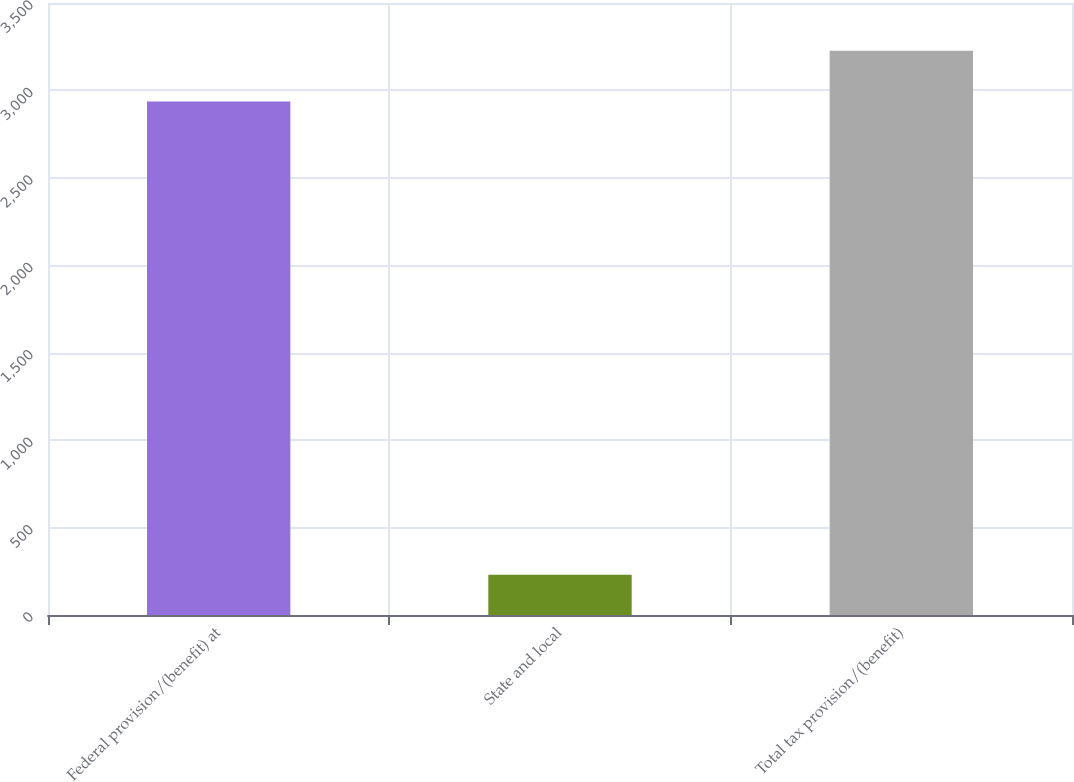Convert chart. <chart><loc_0><loc_0><loc_500><loc_500><bar_chart><fcel>Federal provision/(benefit) at<fcel>State and local<fcel>Total tax provision/(benefit)<nl><fcel>2936<fcel>230<fcel>3227.1<nl></chart> 